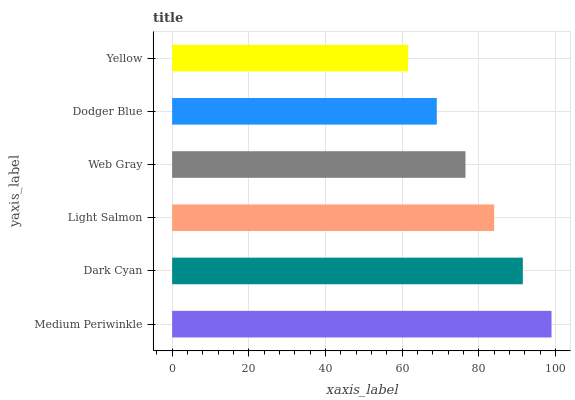Is Yellow the minimum?
Answer yes or no. Yes. Is Medium Periwinkle the maximum?
Answer yes or no. Yes. Is Dark Cyan the minimum?
Answer yes or no. No. Is Dark Cyan the maximum?
Answer yes or no. No. Is Medium Periwinkle greater than Dark Cyan?
Answer yes or no. Yes. Is Dark Cyan less than Medium Periwinkle?
Answer yes or no. Yes. Is Dark Cyan greater than Medium Periwinkle?
Answer yes or no. No. Is Medium Periwinkle less than Dark Cyan?
Answer yes or no. No. Is Light Salmon the high median?
Answer yes or no. Yes. Is Web Gray the low median?
Answer yes or no. Yes. Is Dark Cyan the high median?
Answer yes or no. No. Is Dark Cyan the low median?
Answer yes or no. No. 